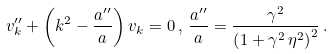<formula> <loc_0><loc_0><loc_500><loc_500>v _ { k } ^ { \prime \prime } + \left ( k ^ { 2 } - \frac { a ^ { \prime \prime } } { a } \right ) v _ { k } = 0 \, , \, \frac { a ^ { \prime \prime } } { a } = \frac { \gamma ^ { 2 } } { \left ( 1 + \gamma ^ { 2 } \, \eta ^ { 2 } \right ) ^ { 2 } } \, .</formula> 